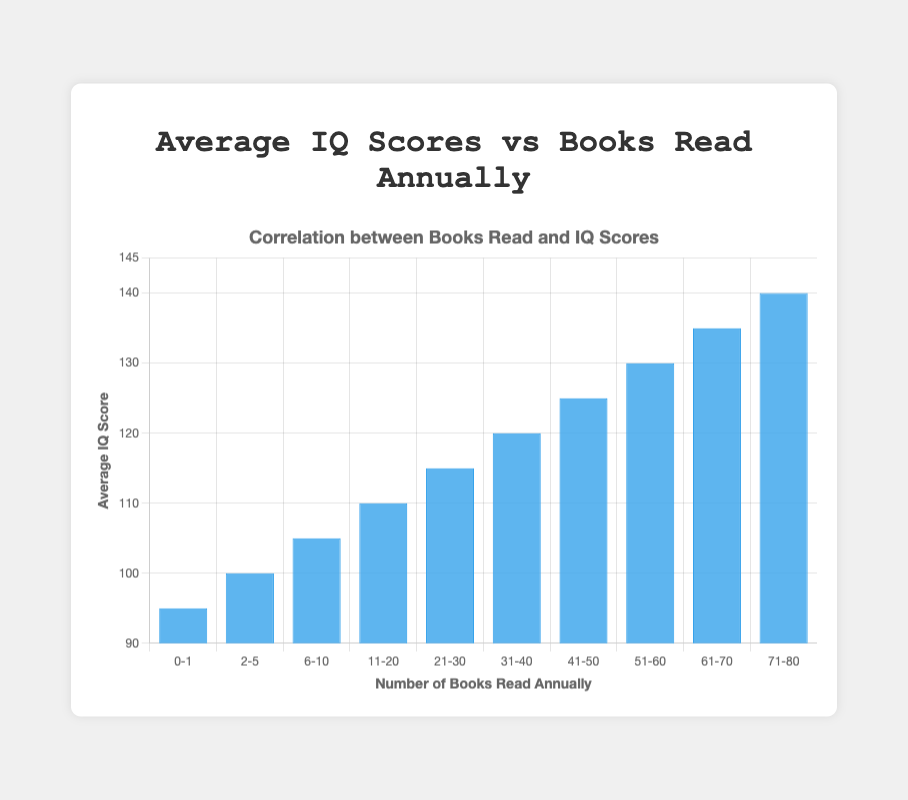What is the average IQ score for people who read 11-20 books annually? The bar corresponding to the "11-20" books read annually shows an average IQ score of 110.
Answer: 110 Which range of books read annually has the highest average IQ score? The highest bar in the chart represents the "71-80" books range with an average IQ score of 140.
Answer: 71-80 What is the difference in average IQ scores between people who read 2-5 books annually and those who read 61-70 books annually? The 2-5 books range has an average IQ score of 100, and the 61-70 books range has an average IQ score of 135. The difference is 135 - 100 which equals 35.
Answer: 35 Are there any categories where the average IQ score is exactly 100? By examining the bars, the "2-5" books range has an average IQ score that is exactly 100.
Answer: Yes By how much does the average IQ score increase when comparing the "0-1" books and the "31-40" books range? The "0-1" books range has an average IQ score of 95, while the "31-40" books range has an average IQ score of 120. The increase is 120 - 95 which equals 25.
Answer: 25 How many categories have an average IQ score above 120? The categories "41-50", "51-60", "61-70", and "71-80" have average IQ scores of 125, 130, 135, and 140 respectively, which are all above 120. This totals to 4 categories.
Answer: 4 Which category shows the smallest average IQ score? The smallest bar in the chart shows the "0-1" books range with an average IQ score of 95.
Answer: 0-1 Is the average IQ score greater for people who read 51-60 books or for those who read 41-50 books? The "51-60" books range has an average IQ score of 130, while the "41-50" books range has an average IQ score of 125. So, 130 is greater than 125.
Answer: 51-60 What is the average IQ score of someone who reads between 21-30 books annually? The bar corresponding to the "21-30" books read annually shows an average IQ score of 115.
Answer: 115 What is the sum of average IQ scores for people who read 6-10 books and those who read 11-20 books annually? The average IQ scores for the "6-10" and "11-20" books ranges are 105 and 110, respectively. Their sum is 105 + 110, which equals 215.
Answer: 215 